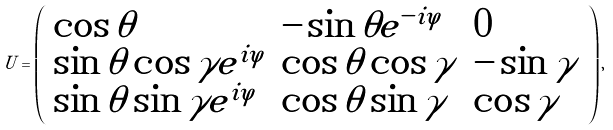<formula> <loc_0><loc_0><loc_500><loc_500>U = \left ( \begin{array} { l l l } \cos \theta & - \sin \theta e ^ { - i \varphi } & 0 \\ \sin \theta \cos \gamma e ^ { i \varphi } & \cos \theta \cos \gamma & - \sin \gamma \\ \sin \theta \sin \gamma e ^ { i \varphi } & \cos \theta \sin \gamma & \cos \gamma \end{array} \right ) ,</formula> 